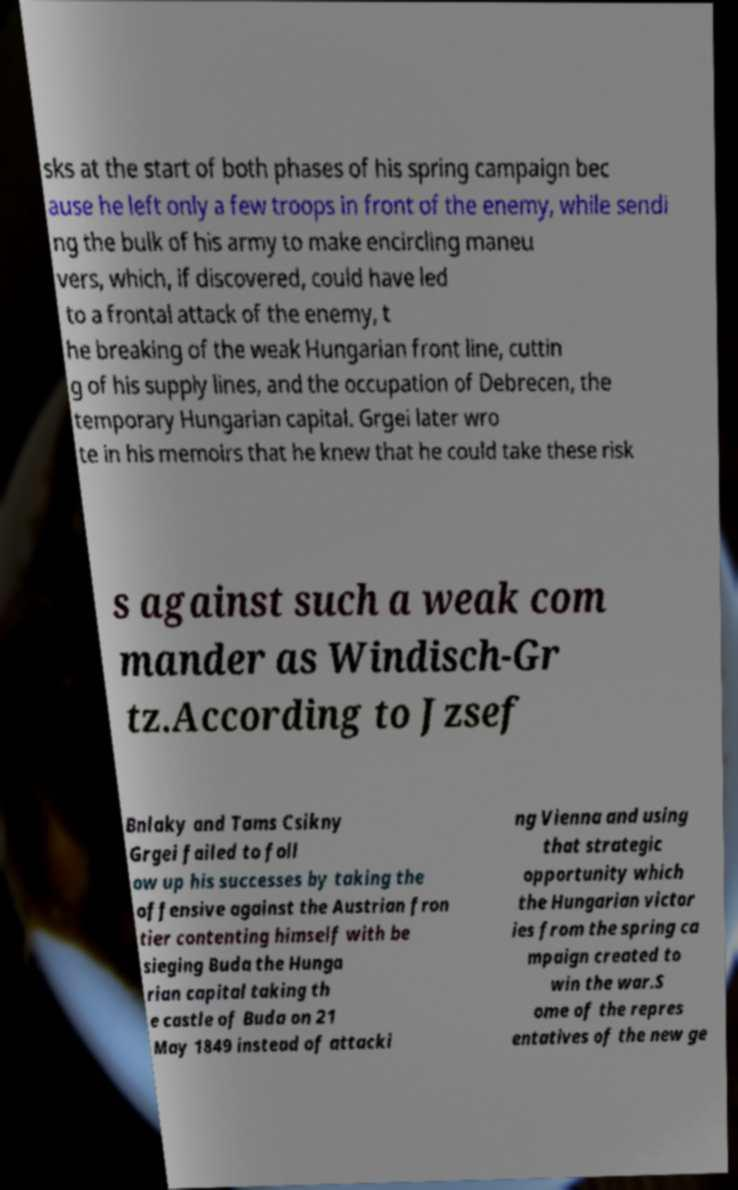Could you assist in decoding the text presented in this image and type it out clearly? sks at the start of both phases of his spring campaign bec ause he left only a few troops in front of the enemy, while sendi ng the bulk of his army to make encircling maneu vers, which, if discovered, could have led to a frontal attack of the enemy, t he breaking of the weak Hungarian front line, cuttin g of his supply lines, and the occupation of Debrecen, the temporary Hungarian capital. Grgei later wro te in his memoirs that he knew that he could take these risk s against such a weak com mander as Windisch-Gr tz.According to Jzsef Bnlaky and Tams Csikny Grgei failed to foll ow up his successes by taking the offensive against the Austrian fron tier contenting himself with be sieging Buda the Hunga rian capital taking th e castle of Buda on 21 May 1849 instead of attacki ng Vienna and using that strategic opportunity which the Hungarian victor ies from the spring ca mpaign created to win the war.S ome of the repres entatives of the new ge 